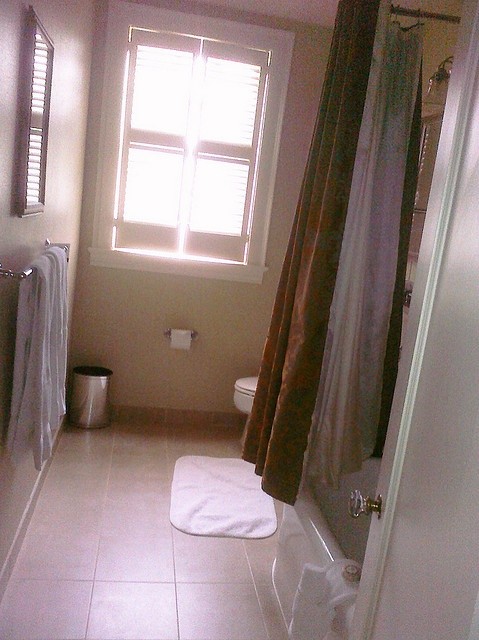Describe the objects in this image and their specific colors. I can see a toilet in gray and darkgray tones in this image. 